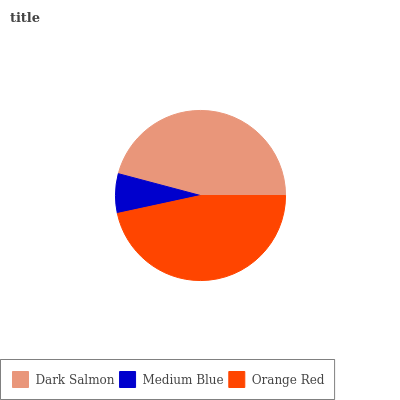Is Medium Blue the minimum?
Answer yes or no. Yes. Is Orange Red the maximum?
Answer yes or no. Yes. Is Orange Red the minimum?
Answer yes or no. No. Is Medium Blue the maximum?
Answer yes or no. No. Is Orange Red greater than Medium Blue?
Answer yes or no. Yes. Is Medium Blue less than Orange Red?
Answer yes or no. Yes. Is Medium Blue greater than Orange Red?
Answer yes or no. No. Is Orange Red less than Medium Blue?
Answer yes or no. No. Is Dark Salmon the high median?
Answer yes or no. Yes. Is Dark Salmon the low median?
Answer yes or no. Yes. Is Orange Red the high median?
Answer yes or no. No. Is Medium Blue the low median?
Answer yes or no. No. 